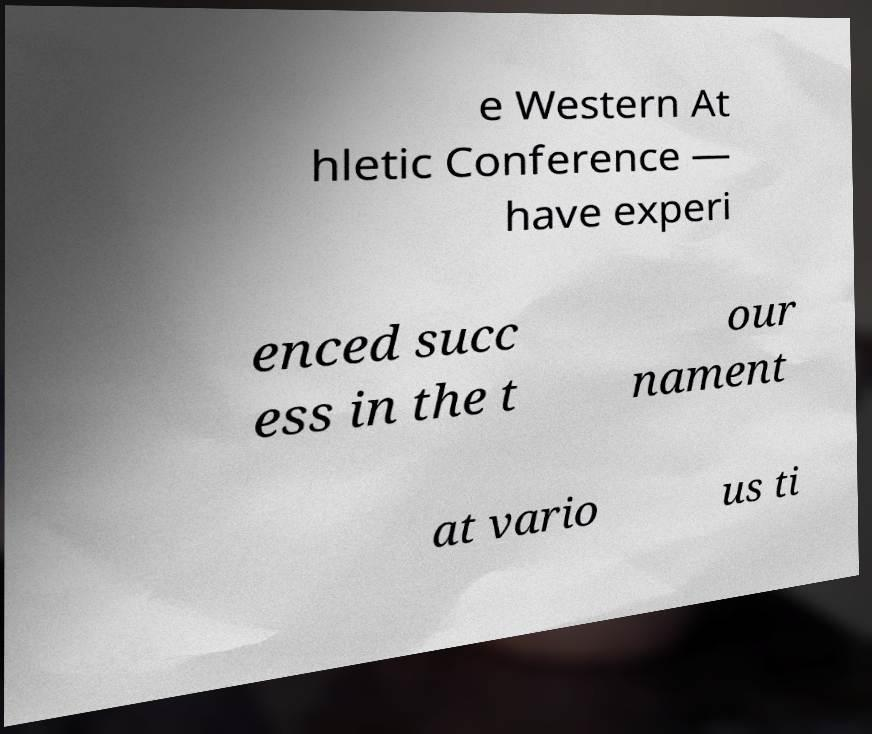Please identify and transcribe the text found in this image. e Western At hletic Conference — have experi enced succ ess in the t our nament at vario us ti 